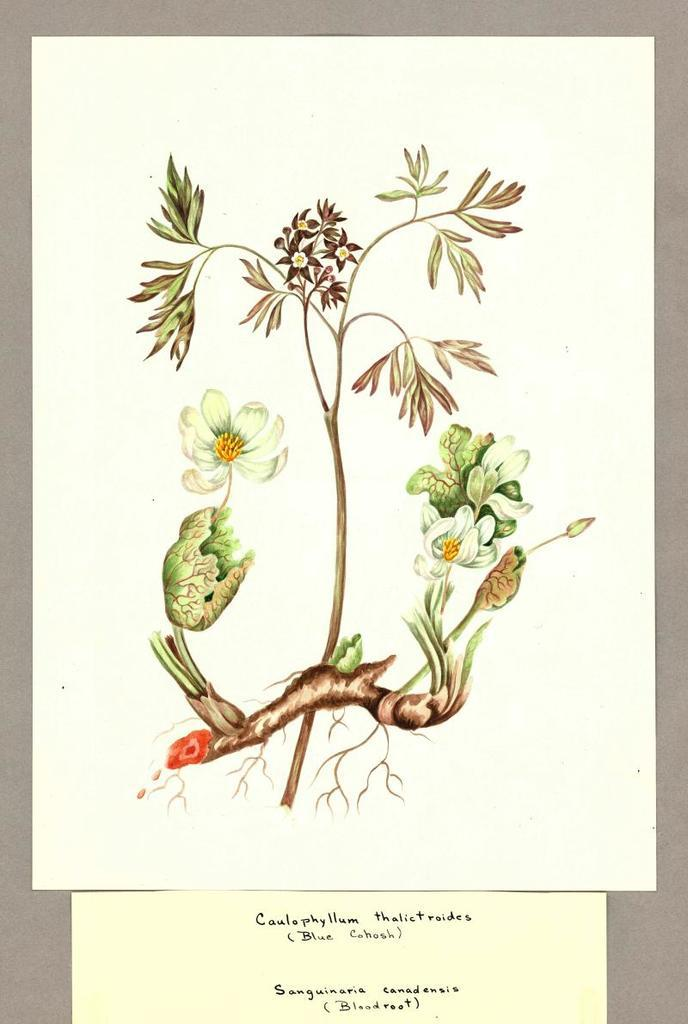What type of images can be seen in the picture? There are pictures of flowers and stems in the image. What is the medium for these images? The pictures are on a paper. How many bikes are parked next to the flowers in the image? There are no bikes present in the image. 